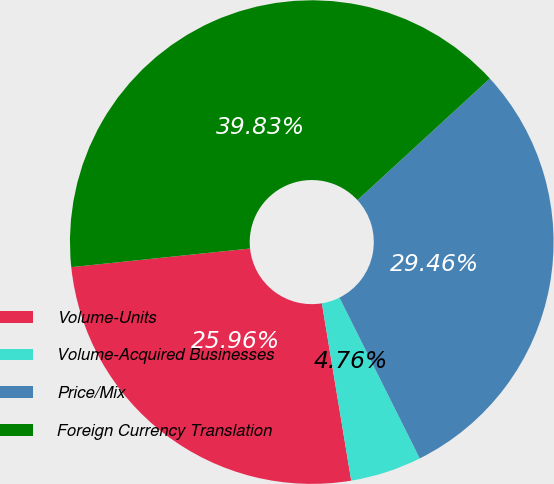<chart> <loc_0><loc_0><loc_500><loc_500><pie_chart><fcel>Volume-Units<fcel>Volume-Acquired Businesses<fcel>Price/Mix<fcel>Foreign Currency Translation<nl><fcel>25.96%<fcel>4.76%<fcel>29.46%<fcel>39.83%<nl></chart> 